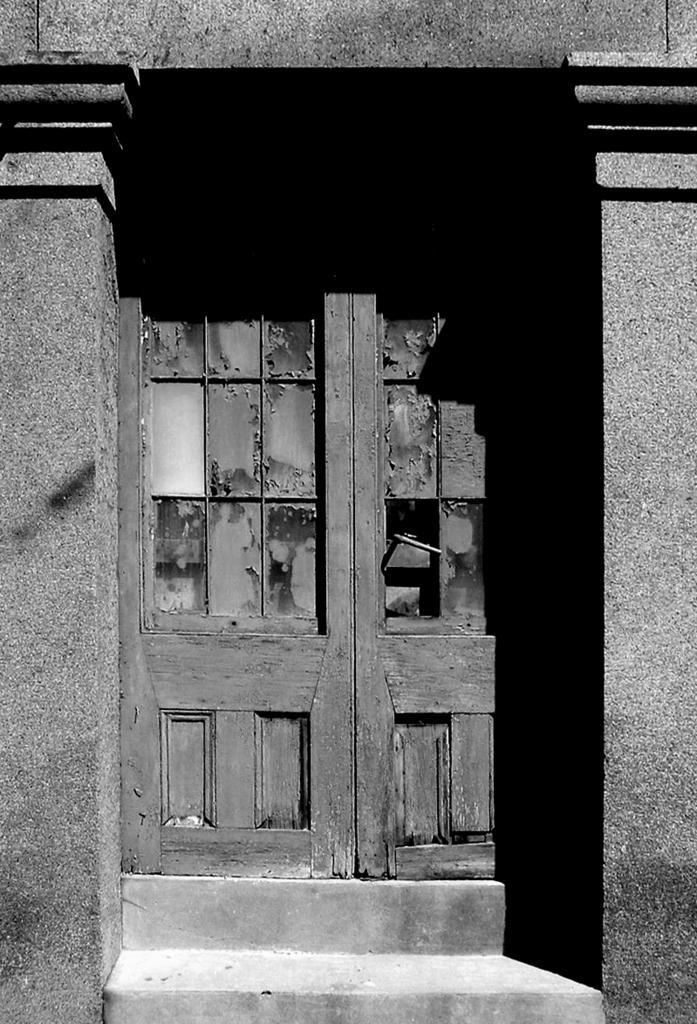How would you summarize this image in a sentence or two? In this picture, it seems like pillars and a door in the foreground. 